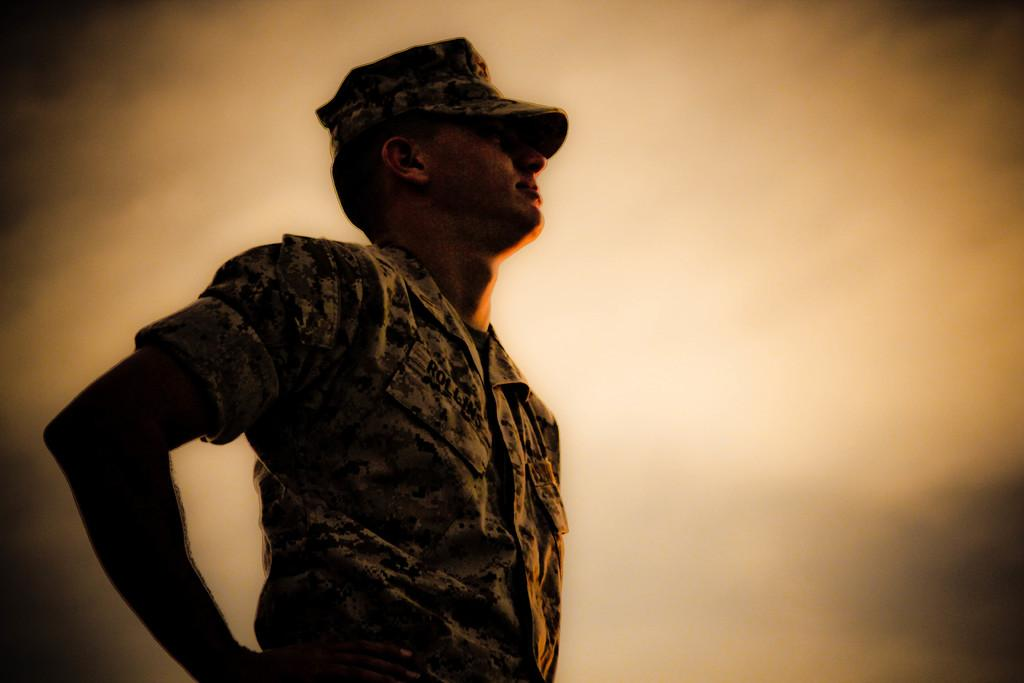What is the main subject of the image? There is a person in the image. What is the person wearing on their head? The person is wearing a cap. What is the person's posture in the image? The person is standing. What type of minister can be seen in the image? There is no minister present in the image; it features a person wearing a cap and standing. What material is the copper frame made of in the image? There is no copper frame present in the image. 